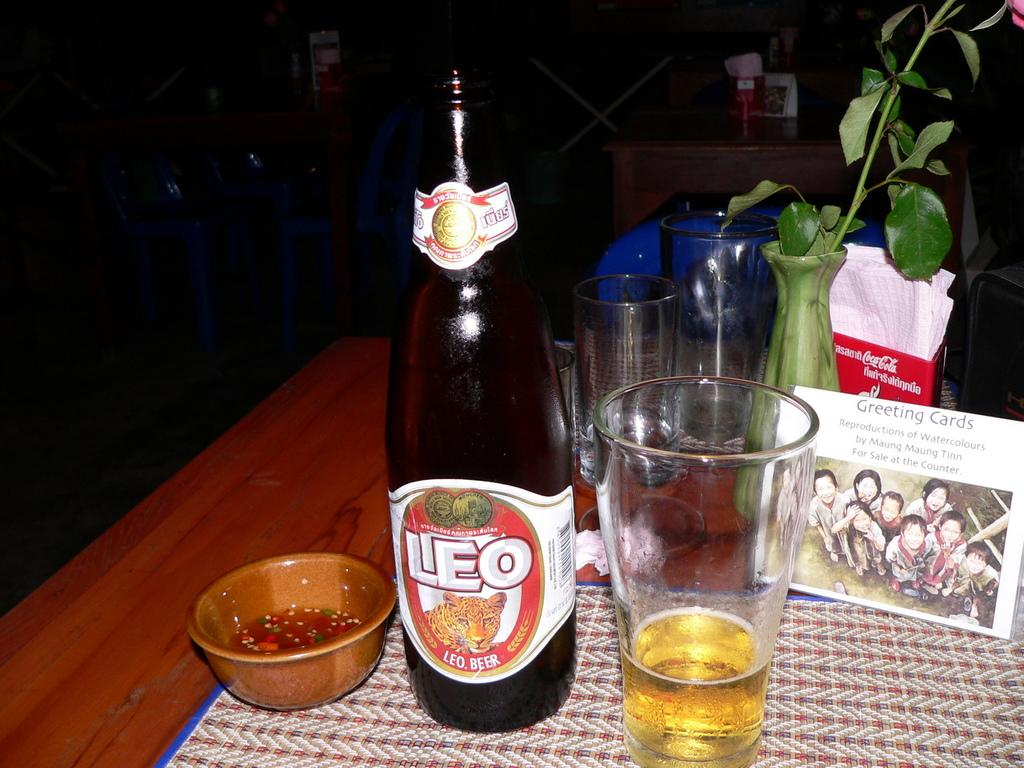<image>
Share a concise interpretation of the image provided. A bottle of beer known as Leo poured into a cup 